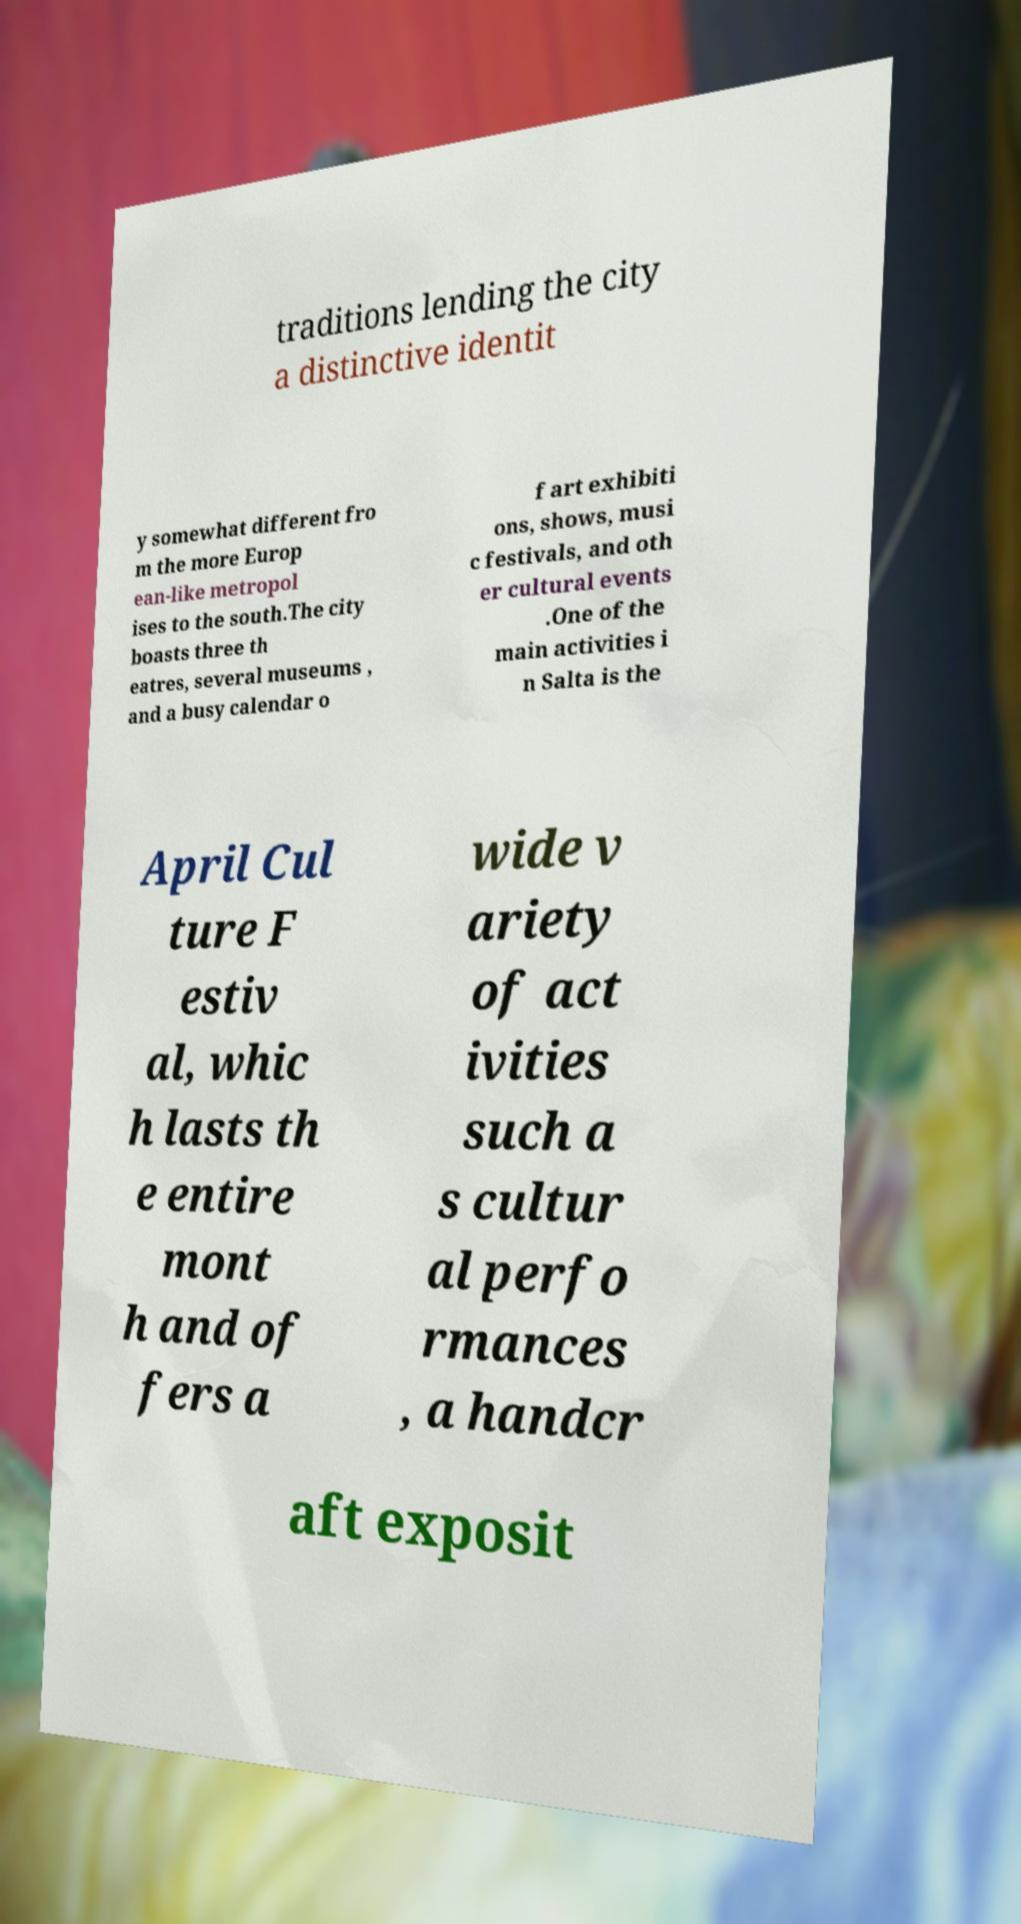Can you accurately transcribe the text from the provided image for me? traditions lending the city a distinctive identit y somewhat different fro m the more Europ ean-like metropol ises to the south.The city boasts three th eatres, several museums , and a busy calendar o f art exhibiti ons, shows, musi c festivals, and oth er cultural events .One of the main activities i n Salta is the April Cul ture F estiv al, whic h lasts th e entire mont h and of fers a wide v ariety of act ivities such a s cultur al perfo rmances , a handcr aft exposit 